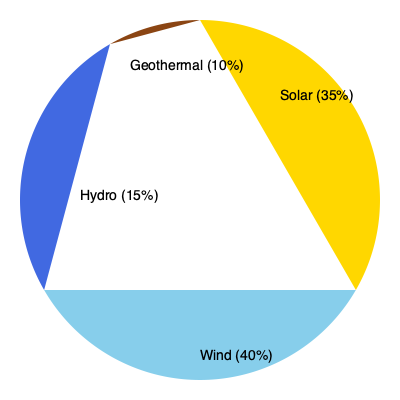Based on the pie chart showing the distribution of renewable energy sources in a particular region, which source contributes the most to the energy mix? Additionally, calculate the ratio of solar to hydro energy production. To answer this question, we need to analyze the pie chart and perform some calculations:

1. Identify the largest segment:
   - Solar: 35%
   - Wind: 40%
   - Hydro: 15%
   - Geothermal: 10%

   Wind has the largest percentage at 40%, so it contributes the most to the energy mix.

2. Calculate the ratio of solar to hydro energy production:
   - Solar: 35%
   - Hydro: 15%

   To find the ratio, we divide the solar percentage by the hydro percentage:

   $\text{Ratio} = \frac{\text{Solar}}{\text{Hydro}} = \frac{35}{15} = \frac{7}{3} \approx 2.33$

   This can be simplified to $7:3$.

Therefore, wind contributes the most to the energy mix, and the ratio of solar to hydro energy production is $7:3$.
Answer: Wind; 7:3 